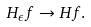<formula> <loc_0><loc_0><loc_500><loc_500>H _ { \epsilon } f \rightarrow H f .</formula> 